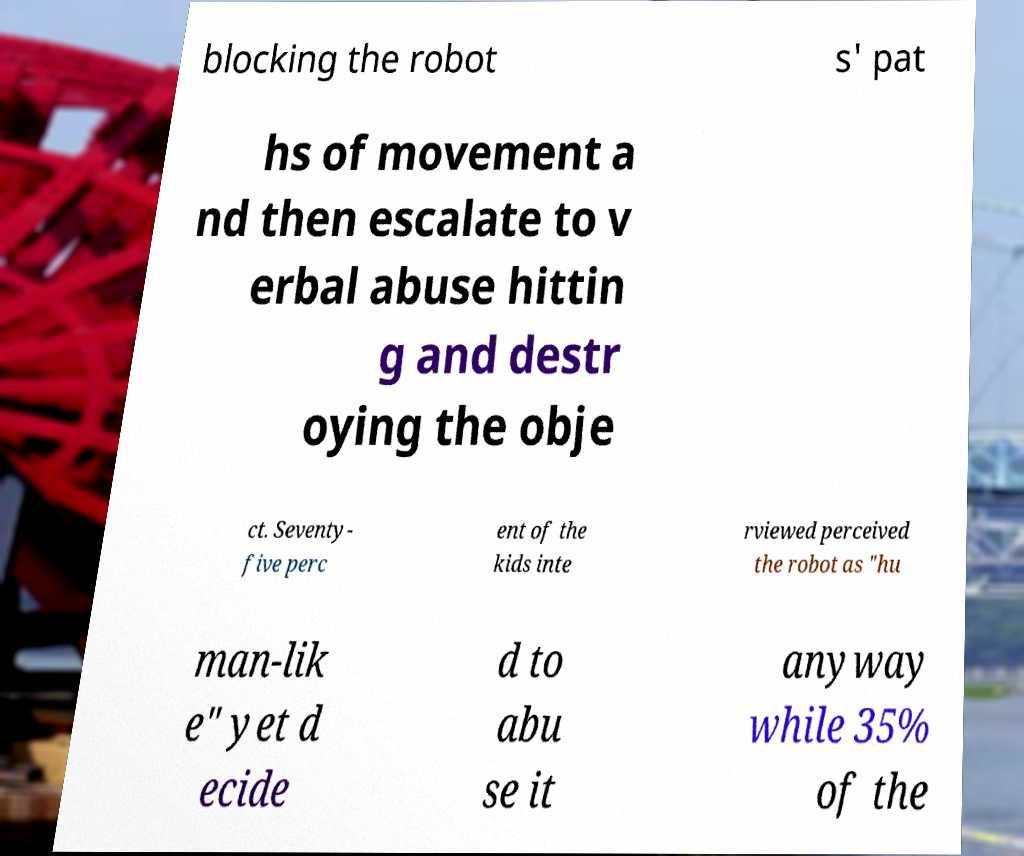Could you extract and type out the text from this image? blocking the robot s' pat hs of movement a nd then escalate to v erbal abuse hittin g and destr oying the obje ct. Seventy- five perc ent of the kids inte rviewed perceived the robot as "hu man-lik e" yet d ecide d to abu se it anyway while 35% of the 